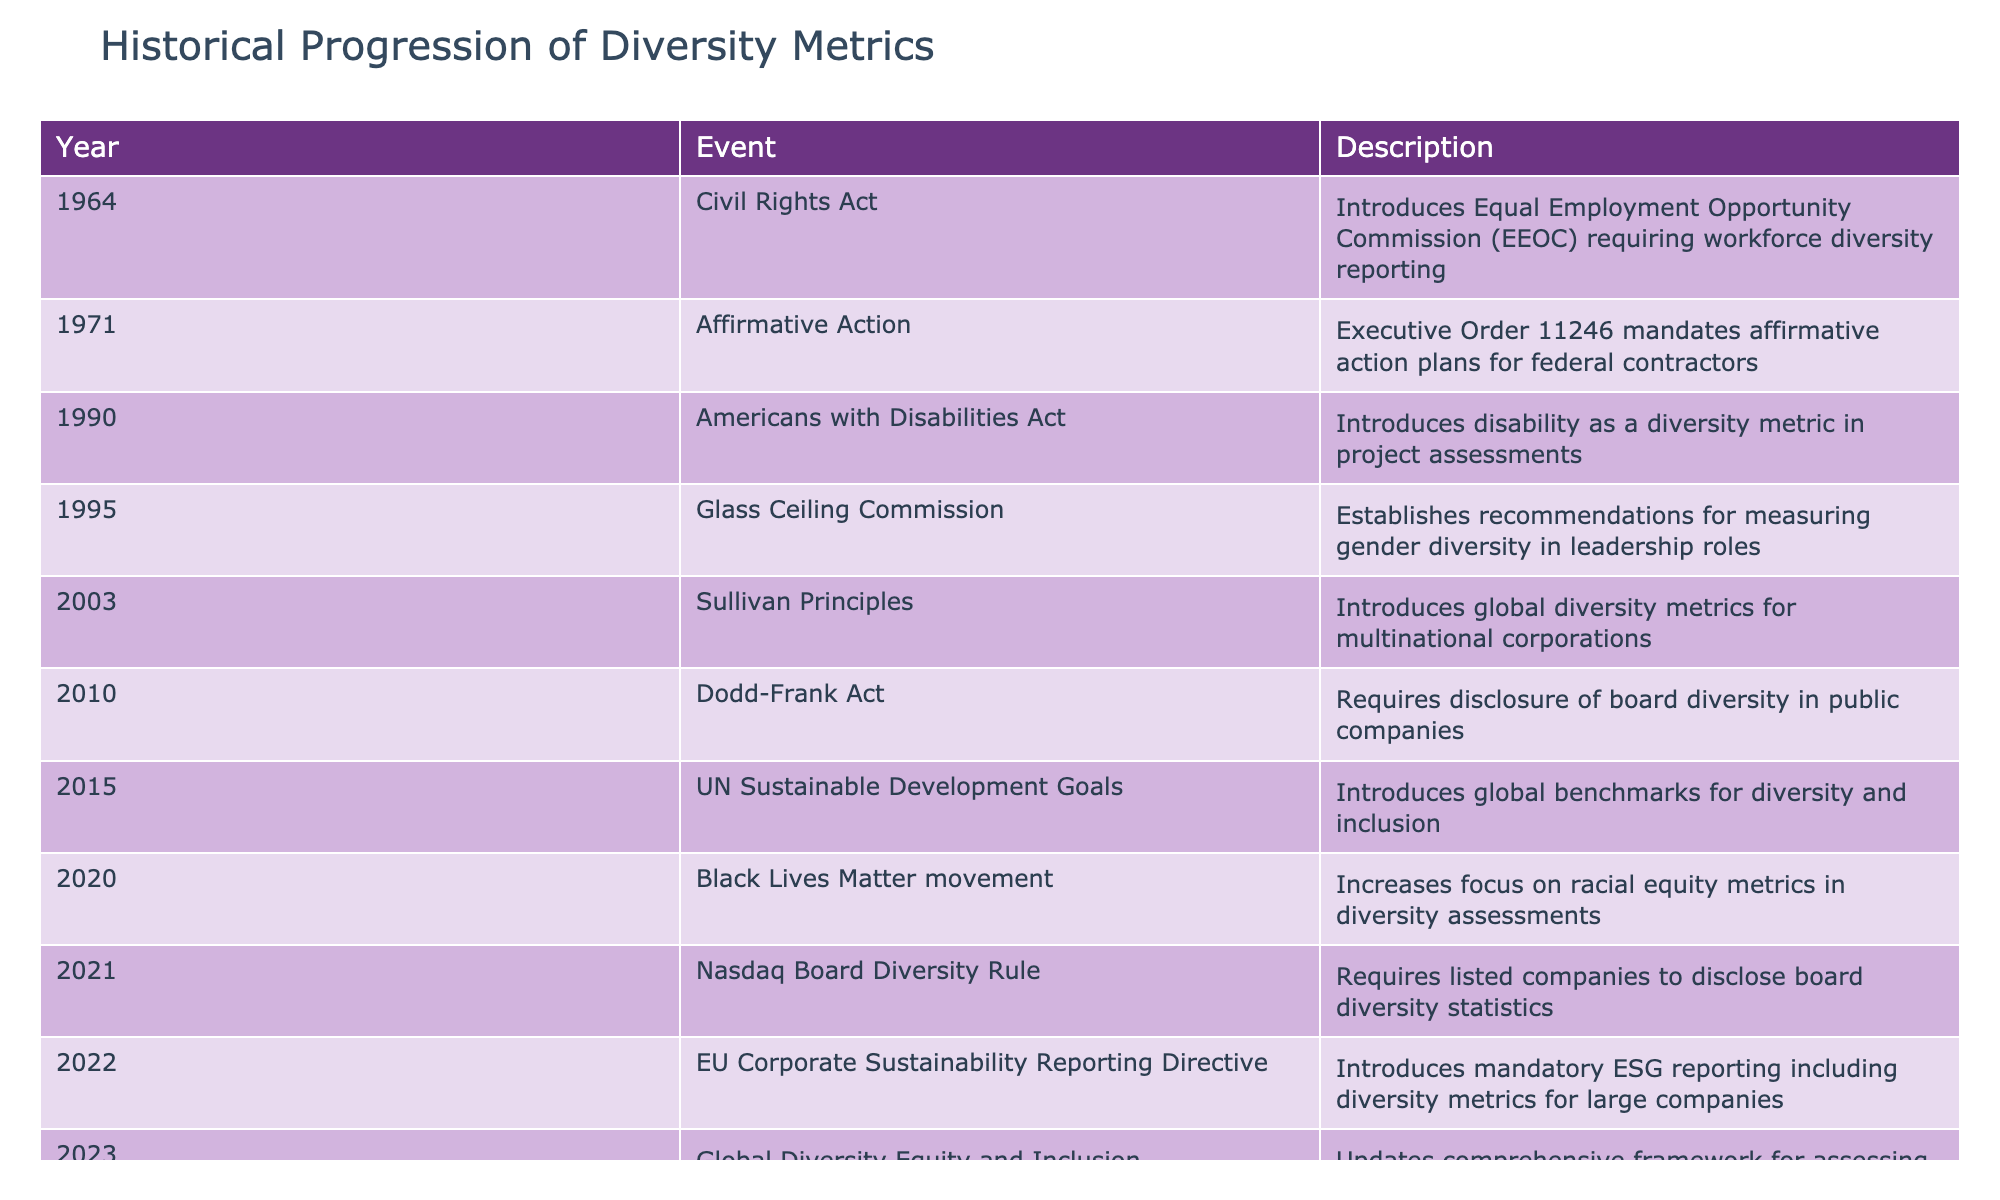What year did the Civil Rights Act introduce the Equal Employment Opportunity Commission? The Civil Rights Act was enacted in 1964, and it specifically introduced the Equal Employment Opportunity Commission which required reporting on workforce diversity.
Answer: 1964 Which event introduced disability as a diversity metric in project assessments? The Americans with Disabilities Act, enacted in 1990, introduced disability as a diversity metric that could be used in project assessments.
Answer: Americans with Disabilities Act How many events from the table focus on racial diversity? The table contains two events that specifically focus on racial diversity: the Black Lives Matter movement in 2020 and the Sullivan Principles in 2003, which emphasize racial equity.
Answer: 2 Did the Nasdaq Board Diversity Rule require companies to disclose gender diversity statistics? No, the Nasdaq Board Diversity Rule requires companies to disclose board diversity statistics, but it does not specify gender; it includes overall diversity metrics instead.
Answer: No Which event is most recent that updates the framework for assessing organizational DEI efforts? The most recent event is the Global Diversity Equity and Inclusion Benchmarks in 2023, which updated the framework for assessing DEI efforts in organizations.
Answer: 2023 What are the first and last events listed in the table? The first event listed is the Civil Rights Act from 1964, and the last event is the Global Diversity Equity and Inclusion Benchmarks from 2023.
Answer: Civil Rights Act and Global Diversity Equity and Inclusion Benchmarks How many years are between the introduction of the Americans with Disabilities Act and the Nasdaq Board Diversity Rule? The Americans with Disabilities Act was enacted in 1990, and the Nasdaq Board Diversity Rule was introduced in 2021. Calculating the difference, we find 2021 - 1990 equals 31 years.
Answer: 31 years Is the Sullivan Principles focused on local or global diversity metrics? The Sullivan Principles, introduced in 2003, are focused on global diversity metrics for multinational corporations, highlighting their international scope.
Answer: Yes What was the primary outcome of the Glass Ceiling Commission? The Glass Ceiling Commission established recommendations specifically for measuring gender diversity in leadership roles, thus attempting to address and promote gender diversity.
Answer: Recommendations for measuring gender diversity 